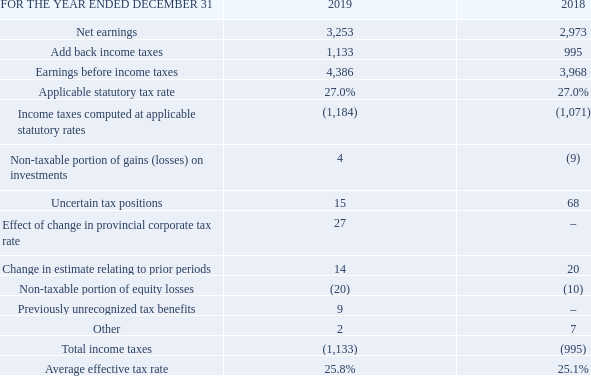4.11 Income Taxes
The following table reconciles the amount of reported income taxes in the income statements with income taxes calculated at a statutory income tax rate of 27.0% for both 2019 and 2018.
Income taxes in 2019 increased by $138 million, compared to 2018, mainly due to higher taxable income and a lower value of uncertain tax positions favourably resolved in 2019 compared to 2018, partly offset by a favourable change in the corporate income tax rate in Alberta in Q2 2019.
What was the statutory income tax rate used for both 2019 and 2018? 27.0%. What was the main factor that led to the increase in income taxes in 2019? Higher taxable income and a lower value of uncertain tax positions favourably resolved in 2019 compared to 2018, partly offset by a favourable change in the corporate income tax rate in alberta in q2 2019. What are the net earnings for 2019? 3,253. What is the change in the applicable statutory tax rate from 2018 to 2019?
Answer scale should be: percent. 27.0% - 27.0% 
Answer: 0. What is the percentage change in the earnings before income taxes from 2018 to 2019?
Answer scale should be: percent. (4,386-3,968)/3,968
Answer: 10.53. What is the total amount of uncertain tax positions in 2018 and 2019? 15+68
Answer: 83. 